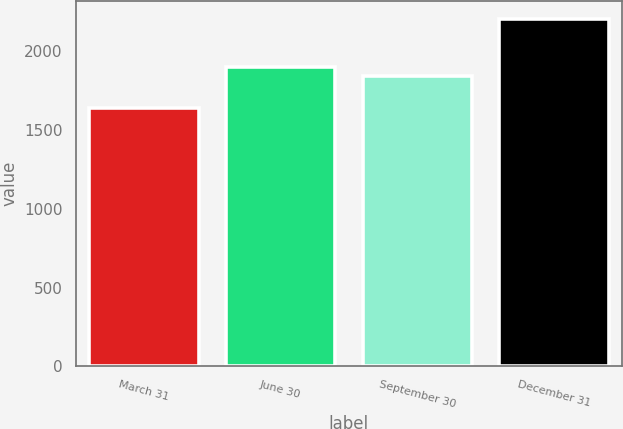Convert chart to OTSL. <chart><loc_0><loc_0><loc_500><loc_500><bar_chart><fcel>March 31<fcel>June 30<fcel>September 30<fcel>December 31<nl><fcel>1637.5<fcel>1898.06<fcel>1841.1<fcel>2207.1<nl></chart> 